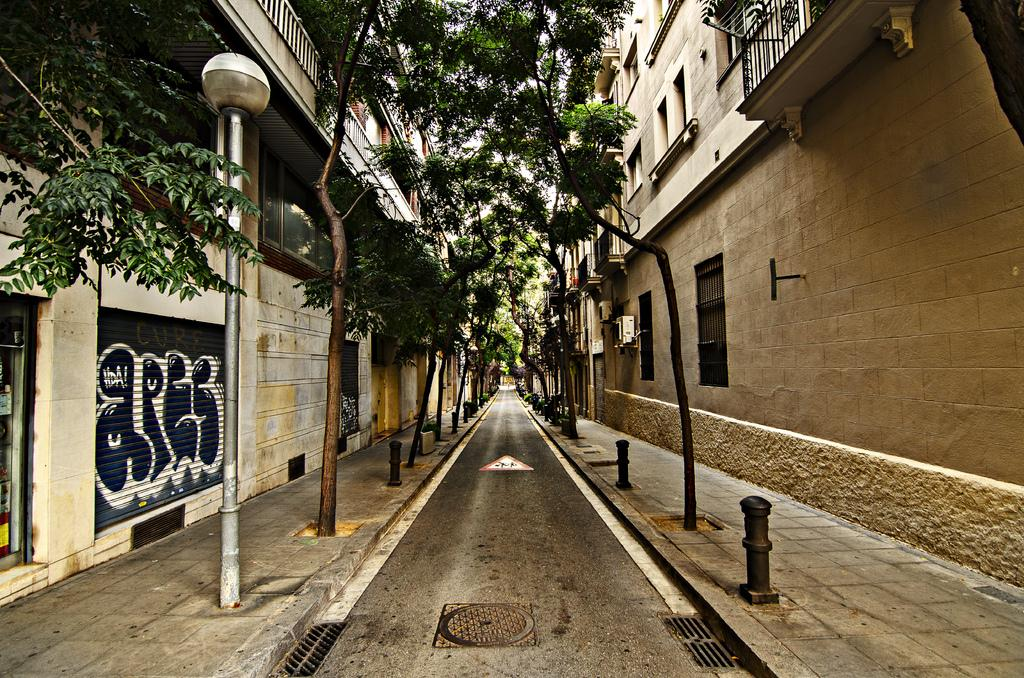What type of structures can be seen in the image? There are buildings in the image. What natural elements are present in the image? There are trees in the image. What type of vertical structures can be seen in the image? Street poles and street lights are visible in the image. What type of equipment is present in the image? Air conditioners are in the image. What type of safety feature is present in the image? Barrier poles are in the image. Where is the celery growing in the image? There is no celery present in the image. What type of lunch is being served in the image? There is no lunch being served in the image. 